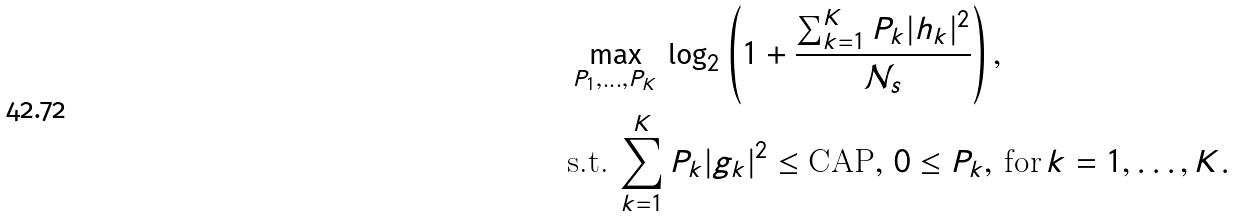Convert formula to latex. <formula><loc_0><loc_0><loc_500><loc_500>& \max _ { P _ { 1 } , \dots , P _ { K } } \, \log _ { 2 } \left ( 1 + \frac { \sum _ { k = 1 } ^ { K } P _ { k } | h _ { k } | ^ { 2 } } { \mathcal { N } _ { s } } \right ) , \\ & \text {s.t.} \, \sum _ { k = 1 } ^ { K } P _ { k } | g _ { k } | ^ { 2 } \leq \text {CAP} , \, 0 \leq P _ { k } , \, \text {for} \, k = 1 , \dots , K .</formula> 